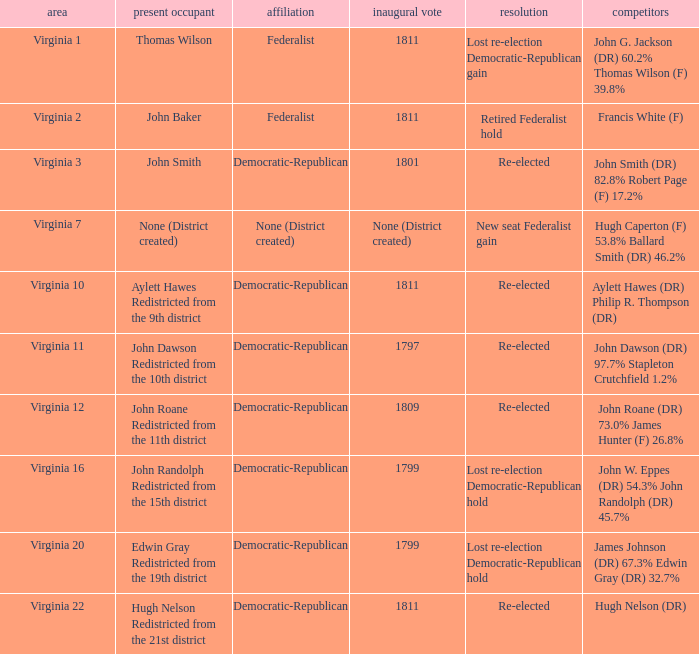Name the party for  john randolph redistricted from the 15th district Democratic-Republican. 